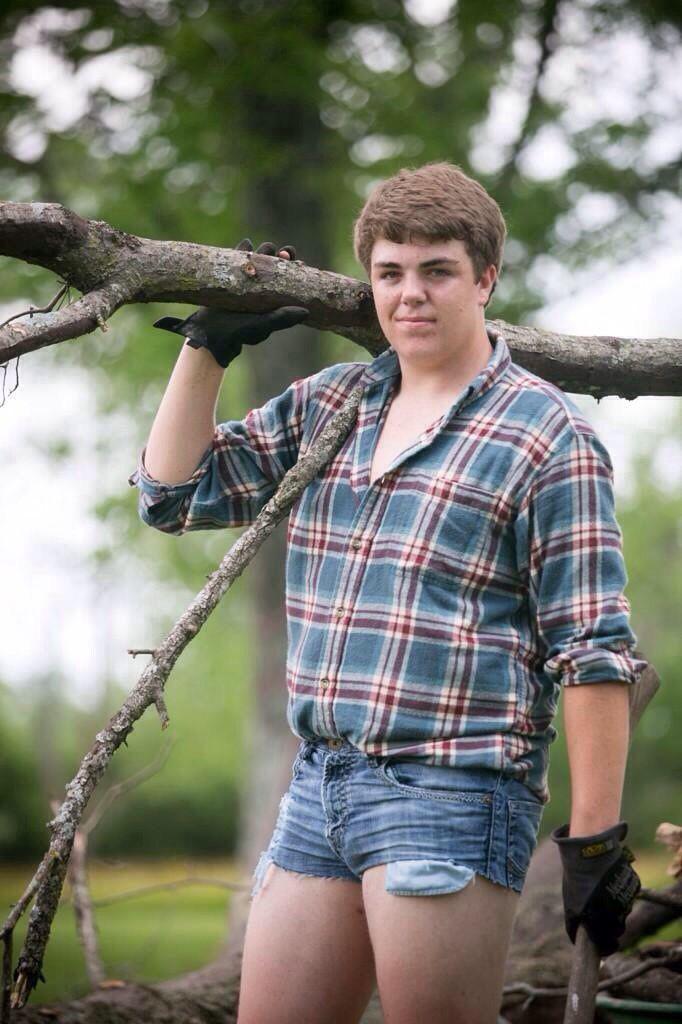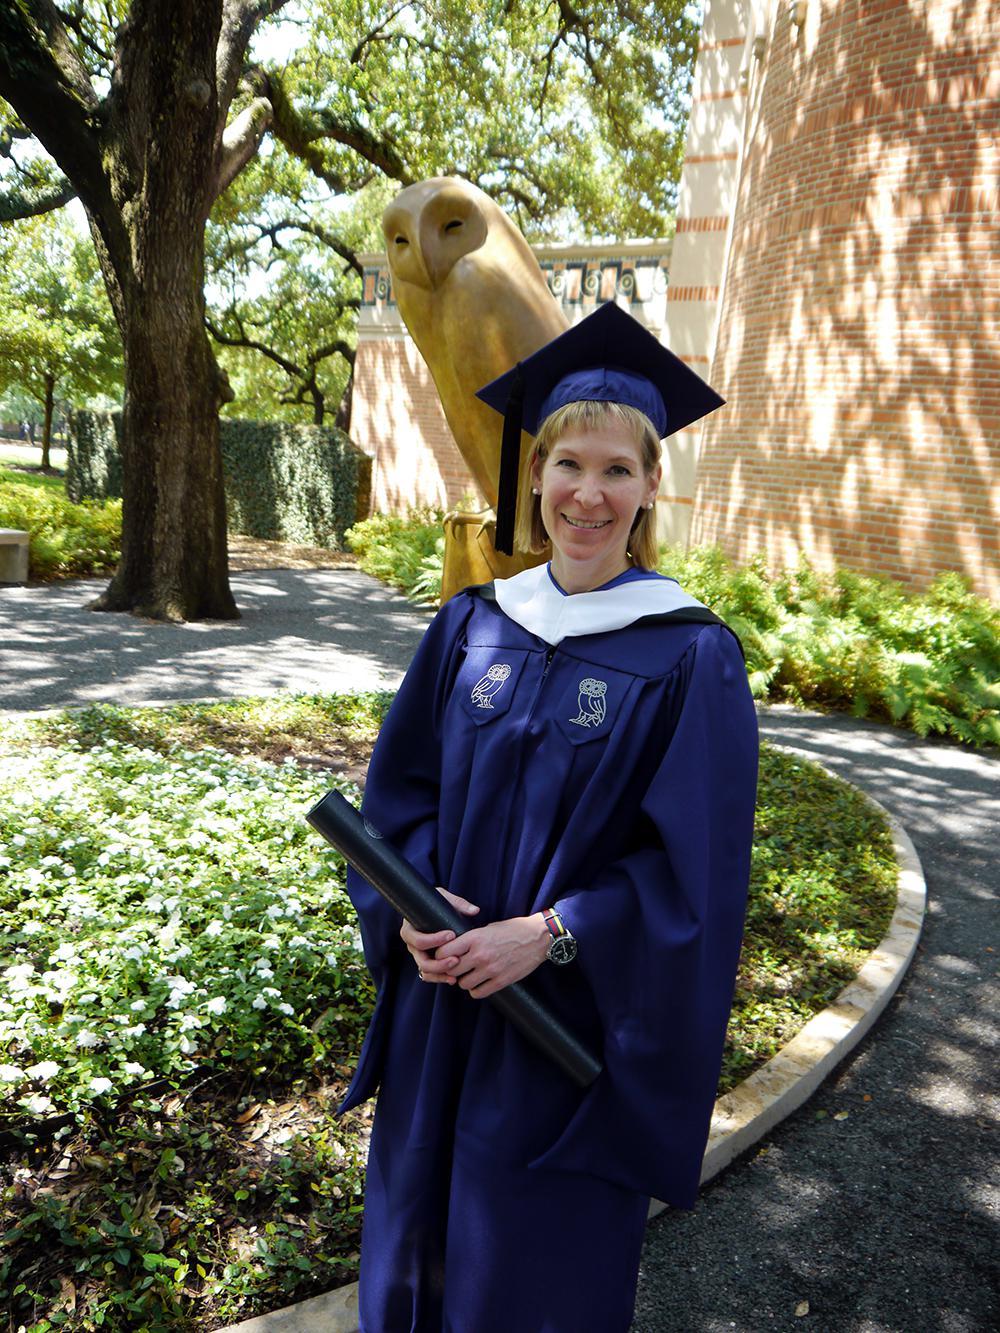The first image is the image on the left, the second image is the image on the right. For the images displayed, is the sentence "One picture has atleast 2 women in it." factually correct? Answer yes or no. No. The first image is the image on the left, the second image is the image on the right. Analyze the images presented: Is the assertion "The left image contains exactly two people wearing graduation uniforms." valid? Answer yes or no. No. 